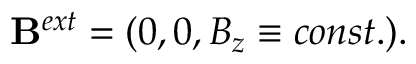Convert formula to latex. <formula><loc_0><loc_0><loc_500><loc_500>B ^ { e x t } = ( 0 , 0 , B _ { z } \equiv c o n s t . ) .</formula> 